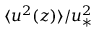Convert formula to latex. <formula><loc_0><loc_0><loc_500><loc_500>\langle u ^ { 2 } ( z ) \rangle / u _ { \ast } ^ { 2 }</formula> 